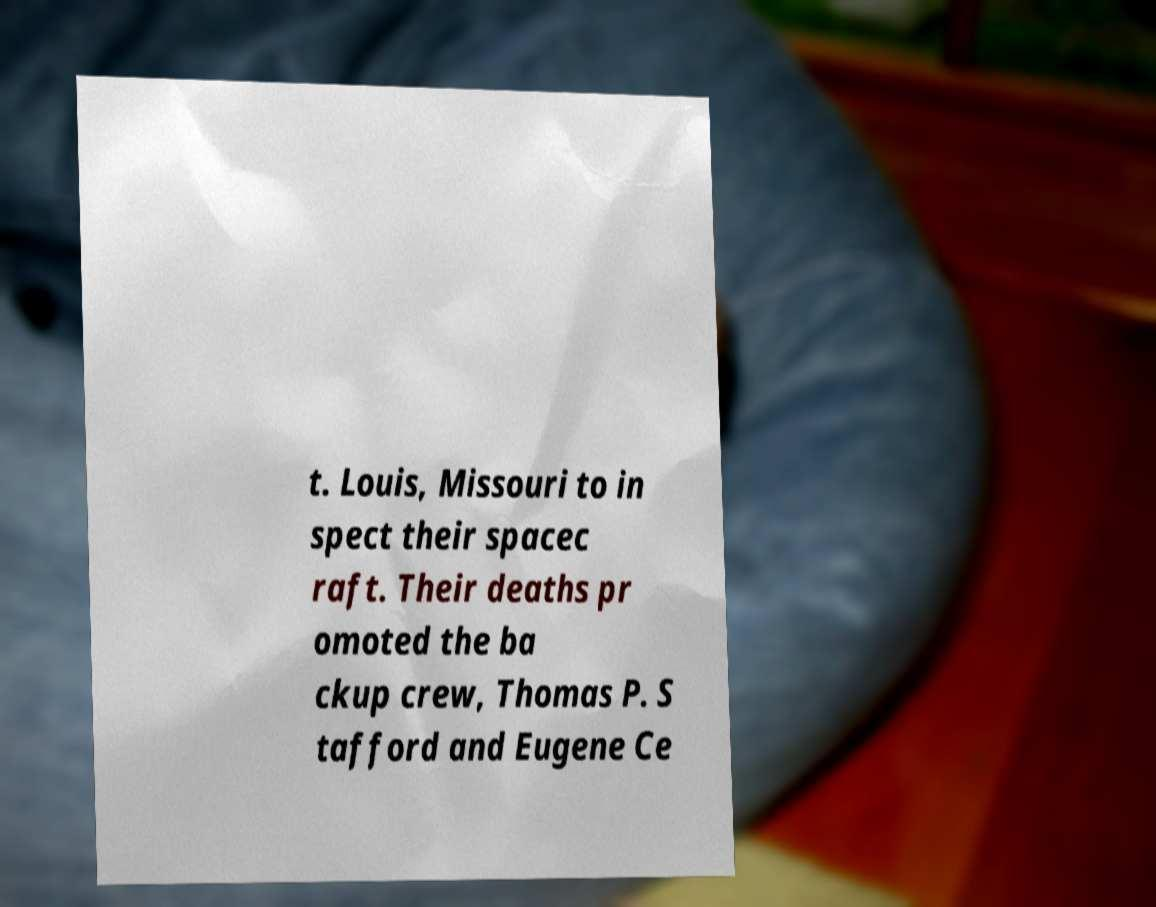What messages or text are displayed in this image? I need them in a readable, typed format. t. Louis, Missouri to in spect their spacec raft. Their deaths pr omoted the ba ckup crew, Thomas P. S tafford and Eugene Ce 